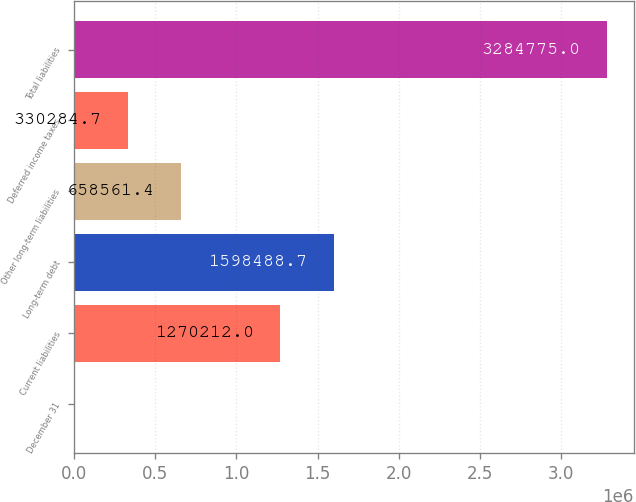<chart> <loc_0><loc_0><loc_500><loc_500><bar_chart><fcel>December 31<fcel>Current liabilities<fcel>Long-term debt<fcel>Other long-term liabilities<fcel>Deferred income taxes<fcel>Total liabilities<nl><fcel>2008<fcel>1.27021e+06<fcel>1.59849e+06<fcel>658561<fcel>330285<fcel>3.28478e+06<nl></chart> 